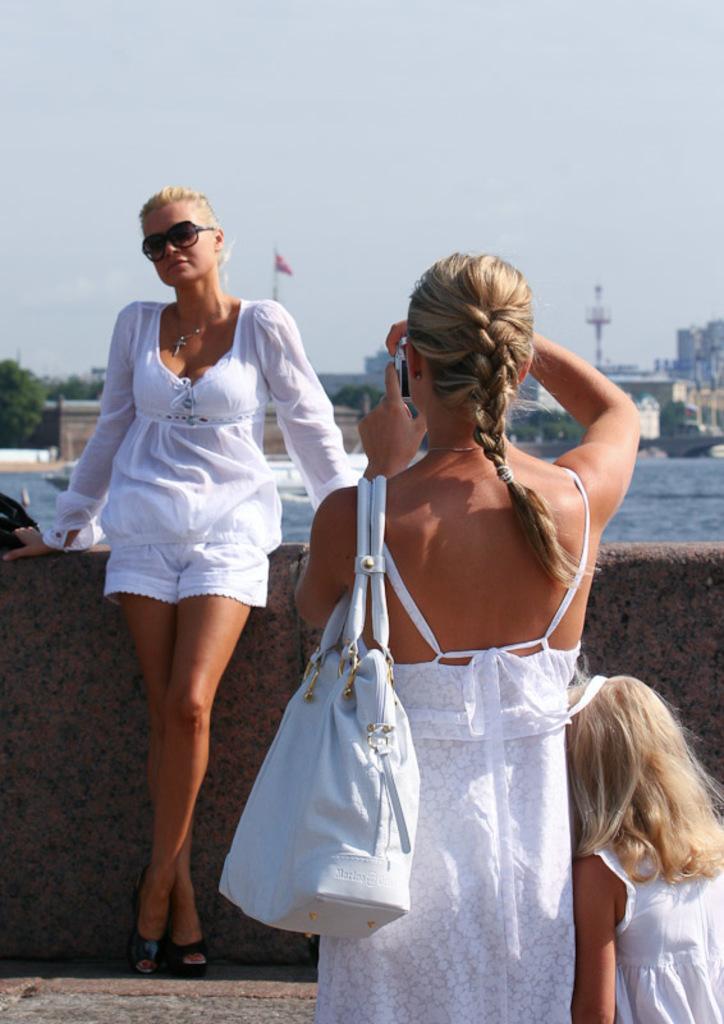How would you summarize this image in a sentence or two? As we can see in the image, there are three persons. The women who is standing here is wearing white color dress and white color bag and clicking camera and the women who is standing here is wearing white color dress and goggles. In the background there is water, buildings and on the top there is sky. 